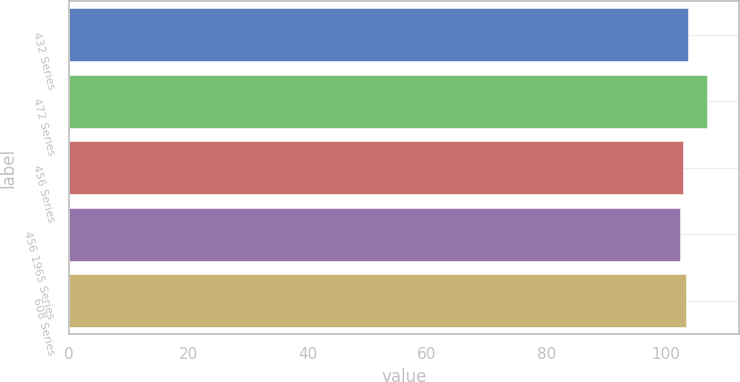Convert chart to OTSL. <chart><loc_0><loc_0><loc_500><loc_500><bar_chart><fcel>432 Series<fcel>472 Series<fcel>456 Series<fcel>456 1965 Series<fcel>608 Series<nl><fcel>103.85<fcel>107<fcel>102.95<fcel>102.5<fcel>103.4<nl></chart> 